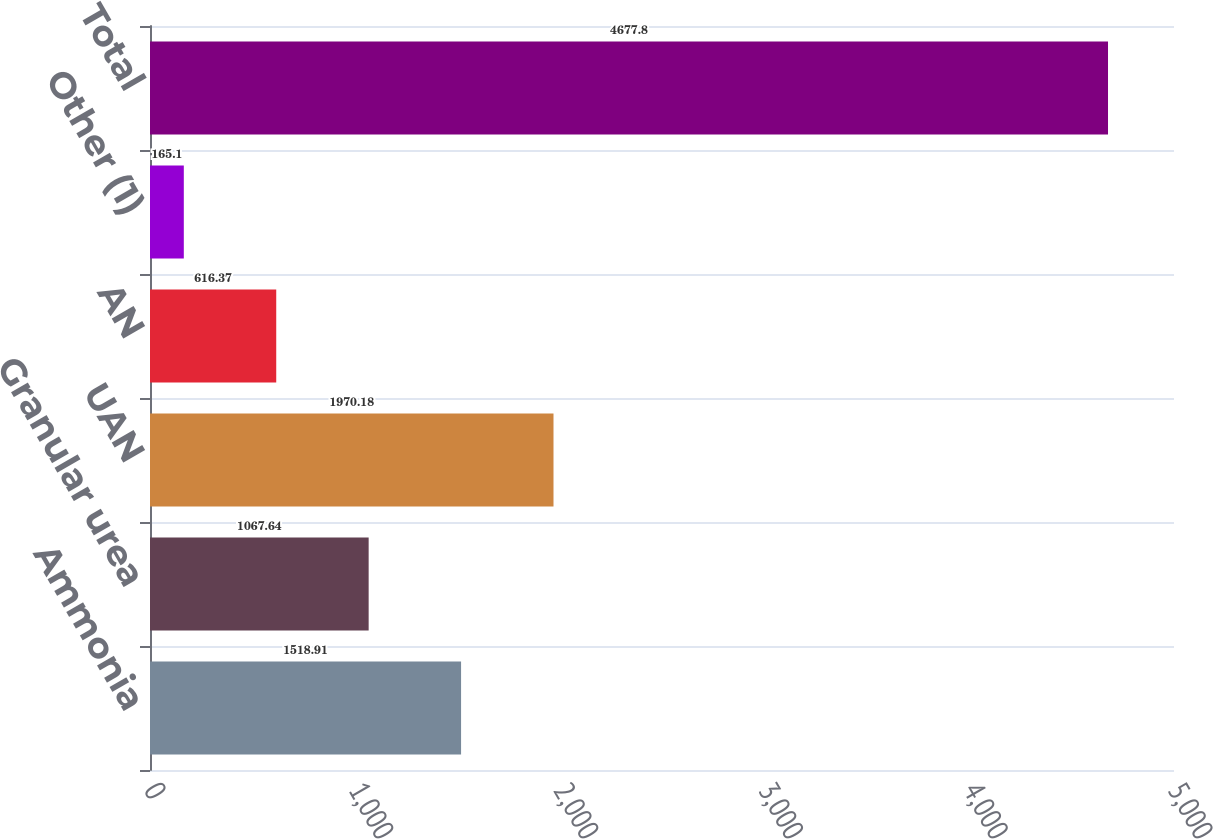Convert chart to OTSL. <chart><loc_0><loc_0><loc_500><loc_500><bar_chart><fcel>Ammonia<fcel>Granular urea<fcel>UAN<fcel>AN<fcel>Other (1)<fcel>Total<nl><fcel>1518.91<fcel>1067.64<fcel>1970.18<fcel>616.37<fcel>165.1<fcel>4677.8<nl></chart> 